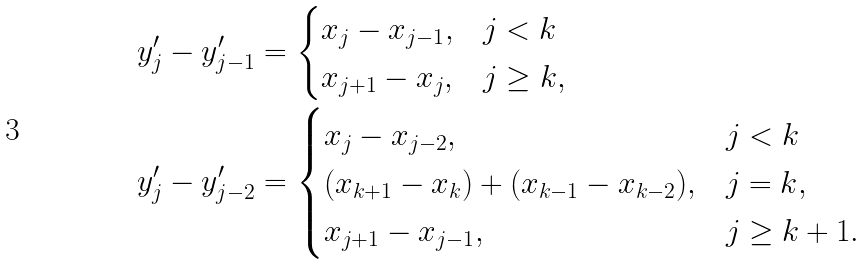<formula> <loc_0><loc_0><loc_500><loc_500>y ^ { \prime } _ { j } - y ^ { \prime } _ { j - 1 } & = \begin{cases} x _ { j } - x _ { j - 1 } , & j < k \\ x _ { j + 1 } - x _ { j } , & j \geq k , \end{cases} \\ y ^ { \prime } _ { j } - y ^ { \prime } _ { j - 2 } & = \begin{cases} x _ { j } - x _ { j - 2 } , & j < k \\ ( x _ { k + 1 } - x _ { k } ) + ( x _ { k - 1 } - x _ { k - 2 } ) , & j = k , \\ x _ { j + 1 } - x _ { j - 1 } , & j \geq k + 1 . \end{cases}</formula> 